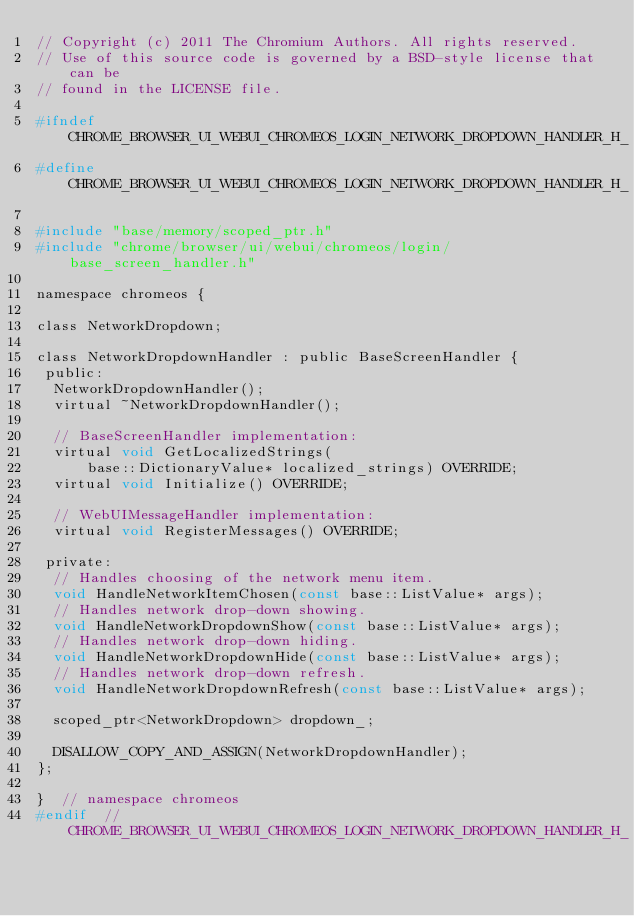<code> <loc_0><loc_0><loc_500><loc_500><_C_>// Copyright (c) 2011 The Chromium Authors. All rights reserved.
// Use of this source code is governed by a BSD-style license that can be
// found in the LICENSE file.

#ifndef CHROME_BROWSER_UI_WEBUI_CHROMEOS_LOGIN_NETWORK_DROPDOWN_HANDLER_H_
#define CHROME_BROWSER_UI_WEBUI_CHROMEOS_LOGIN_NETWORK_DROPDOWN_HANDLER_H_

#include "base/memory/scoped_ptr.h"
#include "chrome/browser/ui/webui/chromeos/login/base_screen_handler.h"

namespace chromeos {

class NetworkDropdown;

class NetworkDropdownHandler : public BaseScreenHandler {
 public:
  NetworkDropdownHandler();
  virtual ~NetworkDropdownHandler();

  // BaseScreenHandler implementation:
  virtual void GetLocalizedStrings(
      base::DictionaryValue* localized_strings) OVERRIDE;
  virtual void Initialize() OVERRIDE;

  // WebUIMessageHandler implementation:
  virtual void RegisterMessages() OVERRIDE;

 private:
  // Handles choosing of the network menu item.
  void HandleNetworkItemChosen(const base::ListValue* args);
  // Handles network drop-down showing.
  void HandleNetworkDropdownShow(const base::ListValue* args);
  // Handles network drop-down hiding.
  void HandleNetworkDropdownHide(const base::ListValue* args);
  // Handles network drop-down refresh.
  void HandleNetworkDropdownRefresh(const base::ListValue* args);

  scoped_ptr<NetworkDropdown> dropdown_;

  DISALLOW_COPY_AND_ASSIGN(NetworkDropdownHandler);
};

}  // namespace chromeos
#endif  // CHROME_BROWSER_UI_WEBUI_CHROMEOS_LOGIN_NETWORK_DROPDOWN_HANDLER_H_
</code> 